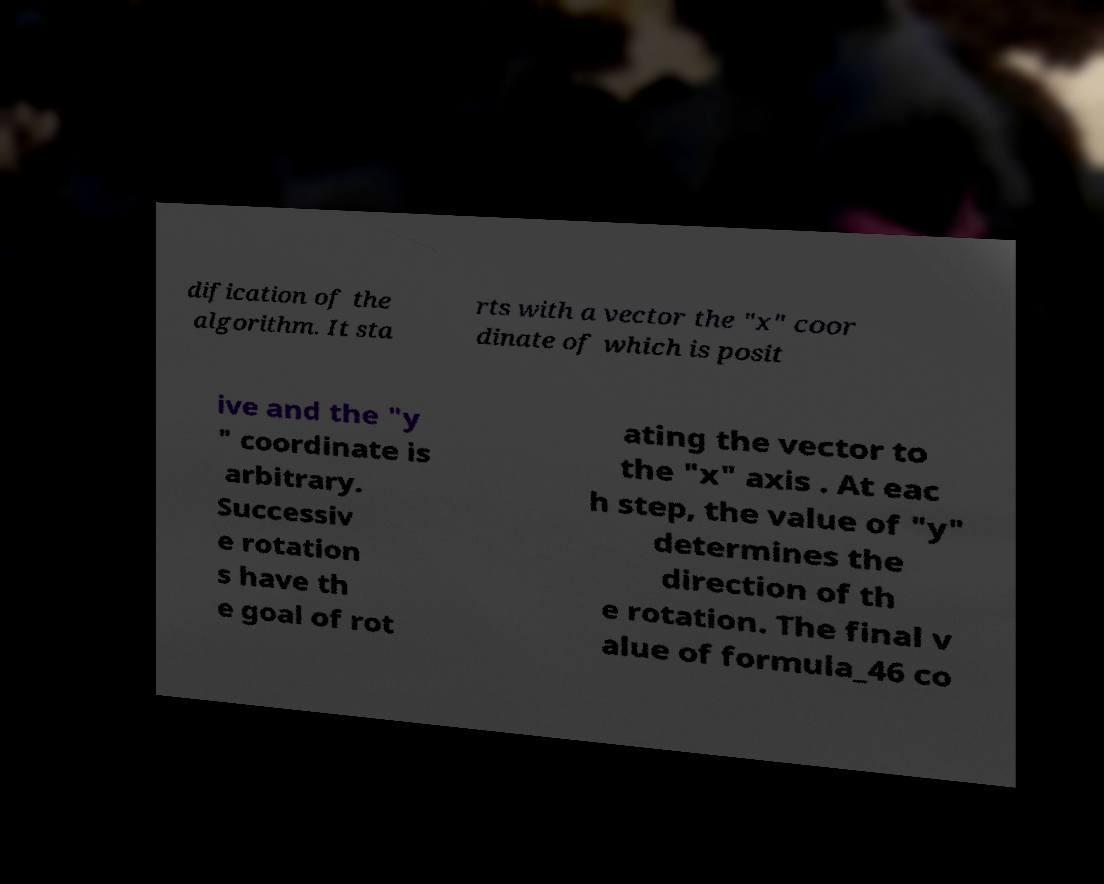Please read and relay the text visible in this image. What does it say? dification of the algorithm. It sta rts with a vector the "x" coor dinate of which is posit ive and the "y " coordinate is arbitrary. Successiv e rotation s have th e goal of rot ating the vector to the "x" axis . At eac h step, the value of "y" determines the direction of th e rotation. The final v alue of formula_46 co 